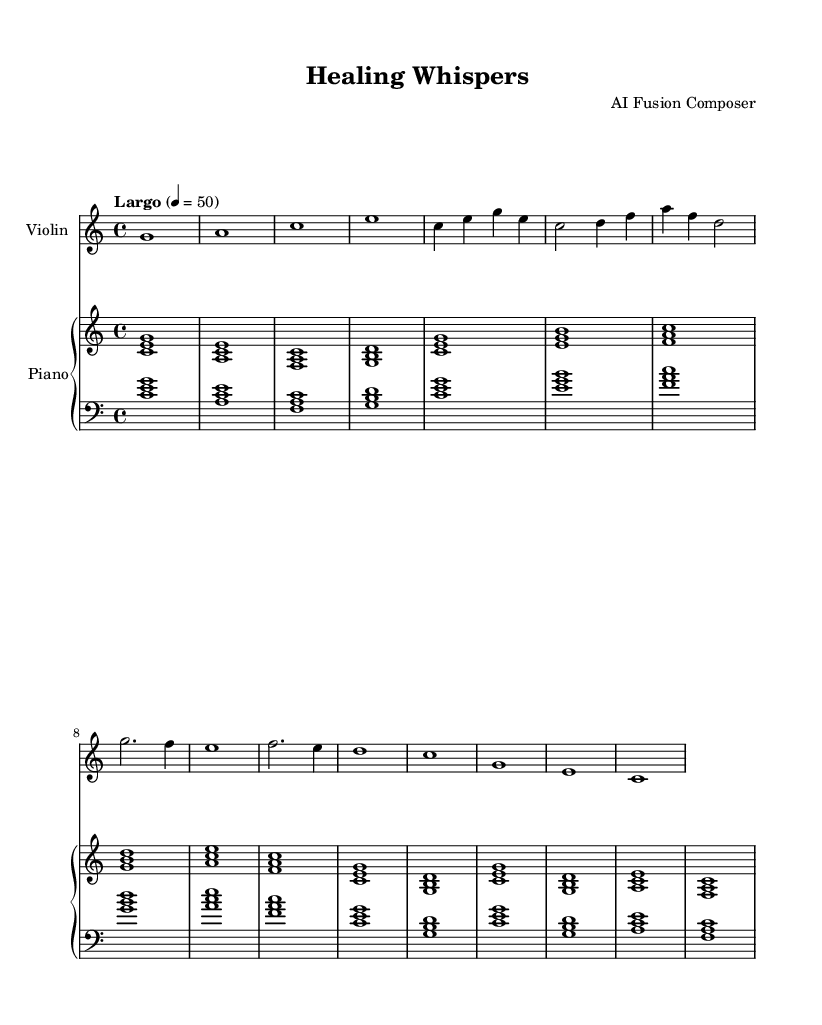What is the key signature of this music? The key signature is identified by looking at the beginning of the music where it shows no sharps or flats, indicating a key of C major.
Answer: C major What is the time signature of this music? The time signature is indicated at the start of the score, which shows "4/4," meaning there are four beats in each measure and the quarter note gets one beat.
Answer: 4/4 What is the tempo marking of this piece? The tempo marking is located above the staff and indicates "Largo" at 4 = 50, which describes the pace of the piece as slow.
Answer: Largo How many measures does the violin part contain? By counting the vertical lines (bar lines) that separate the music into measures, we find the violin part contains 8 measures.
Answer: 8 Which instruments are featured in this composition? The instruments are listed in the staff labels at the beginning of the score, where it clearly mentions "Violin" and "Piano."
Answer: Violin and Piano How does the piano accompaniment change throughout the piece? The piano accompaniment consists of chords that regularly follow a pattern of arpeggiated triads, providing harmony that supports the melodic line played by the violin, thus creating a calming atmosphere typical of ambient-classical fusion.
Answer: Arpeggiated triads What is the overall mood this piece aims to convey? The soft, melodic lines of the violin combined with the gentle harmonies of the piano suggest a tranquil atmosphere suitable for meditation and relaxation, characteristic of the ambient-classical fusion genre.
Answer: Tranquil atmosphere 